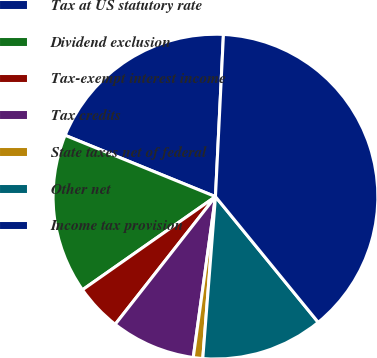Convert chart. <chart><loc_0><loc_0><loc_500><loc_500><pie_chart><fcel>Tax at US statutory rate<fcel>Dividend exclusion<fcel>Tax-exempt interest income<fcel>Tax credits<fcel>State taxes net of federal<fcel>Other net<fcel>Income tax provision<nl><fcel>19.62%<fcel>15.89%<fcel>4.68%<fcel>8.41%<fcel>0.94%<fcel>12.15%<fcel>38.31%<nl></chart> 